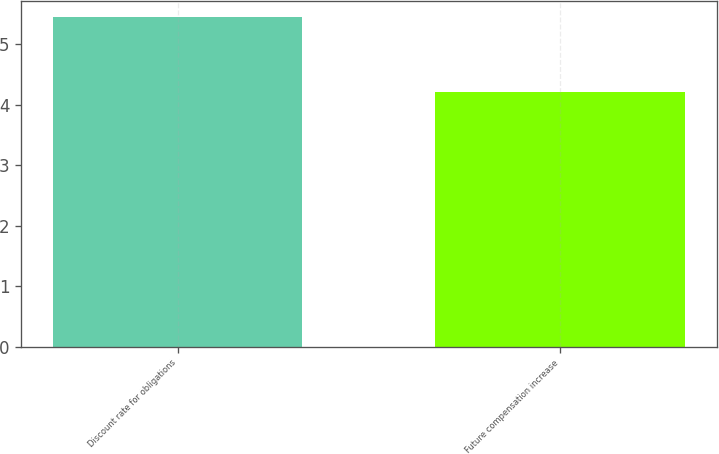<chart> <loc_0><loc_0><loc_500><loc_500><bar_chart><fcel>Discount rate for obligations<fcel>Future compensation increase<nl><fcel>5.44<fcel>4.21<nl></chart> 